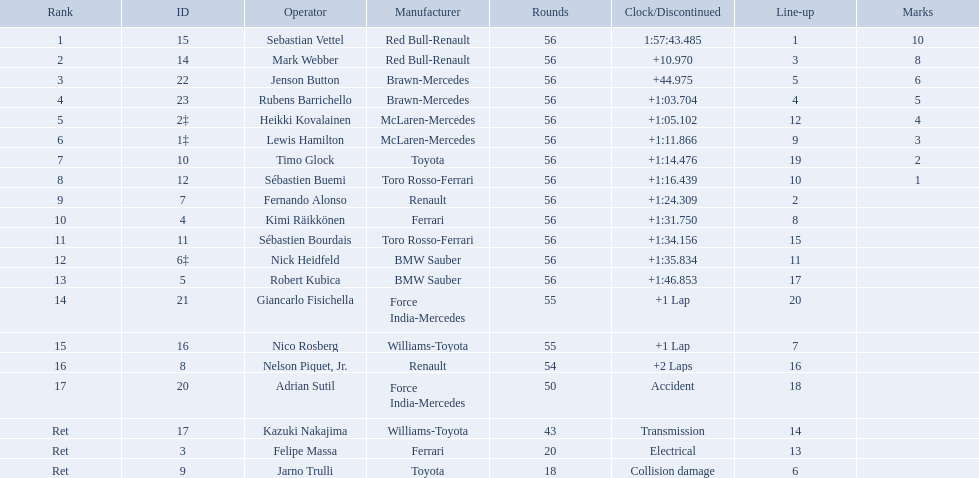Who are all of the drivers? Sebastian Vettel, Mark Webber, Jenson Button, Rubens Barrichello, Heikki Kovalainen, Lewis Hamilton, Timo Glock, Sébastien Buemi, Fernando Alonso, Kimi Räikkönen, Sébastien Bourdais, Nick Heidfeld, Robert Kubica, Giancarlo Fisichella, Nico Rosberg, Nelson Piquet, Jr., Adrian Sutil, Kazuki Nakajima, Felipe Massa, Jarno Trulli. Who were their constructors? Red Bull-Renault, Red Bull-Renault, Brawn-Mercedes, Brawn-Mercedes, McLaren-Mercedes, McLaren-Mercedes, Toyota, Toro Rosso-Ferrari, Renault, Ferrari, Toro Rosso-Ferrari, BMW Sauber, BMW Sauber, Force India-Mercedes, Williams-Toyota, Renault, Force India-Mercedes, Williams-Toyota, Ferrari, Toyota. Who was the first listed driver to not drive a ferrari?? Sebastian Vettel. Which drivers took part in the 2009 chinese grand prix? Sebastian Vettel, Mark Webber, Jenson Button, Rubens Barrichello, Heikki Kovalainen, Lewis Hamilton, Timo Glock, Sébastien Buemi, Fernando Alonso, Kimi Räikkönen, Sébastien Bourdais, Nick Heidfeld, Robert Kubica, Giancarlo Fisichella, Nico Rosberg, Nelson Piquet, Jr., Adrian Sutil, Kazuki Nakajima, Felipe Massa, Jarno Trulli. Of these, who completed all 56 laps? Sebastian Vettel, Mark Webber, Jenson Button, Rubens Barrichello, Heikki Kovalainen, Lewis Hamilton, Timo Glock, Sébastien Buemi, Fernando Alonso, Kimi Räikkönen, Sébastien Bourdais, Nick Heidfeld, Robert Kubica. Of these, which did ferrari not participate as a constructor? Sebastian Vettel, Mark Webber, Jenson Button, Rubens Barrichello, Heikki Kovalainen, Lewis Hamilton, Timo Glock, Fernando Alonso, Kimi Räikkönen, Nick Heidfeld, Robert Kubica. Of the remaining, which is in pos 1? Sebastian Vettel. Which drivers raced in the 2009 chinese grand prix? Sebastian Vettel, Mark Webber, Jenson Button, Rubens Barrichello, Heikki Kovalainen, Lewis Hamilton, Timo Glock, Sébastien Buemi, Fernando Alonso, Kimi Räikkönen, Sébastien Bourdais, Nick Heidfeld, Robert Kubica, Giancarlo Fisichella, Nico Rosberg, Nelson Piquet, Jr., Adrian Sutil, Kazuki Nakajima, Felipe Massa, Jarno Trulli. Of the drivers in the 2009 chinese grand prix, which finished the race? Sebastian Vettel, Mark Webber, Jenson Button, Rubens Barrichello, Heikki Kovalainen, Lewis Hamilton, Timo Glock, Sébastien Buemi, Fernando Alonso, Kimi Räikkönen, Sébastien Bourdais, Nick Heidfeld, Robert Kubica. Of the drivers who finished the race, who had the slowest time? Robert Kubica. Which drive retired because of electrical issues? Felipe Massa. Which driver retired due to accident? Adrian Sutil. Which driver retired due to collision damage? Jarno Trulli. 